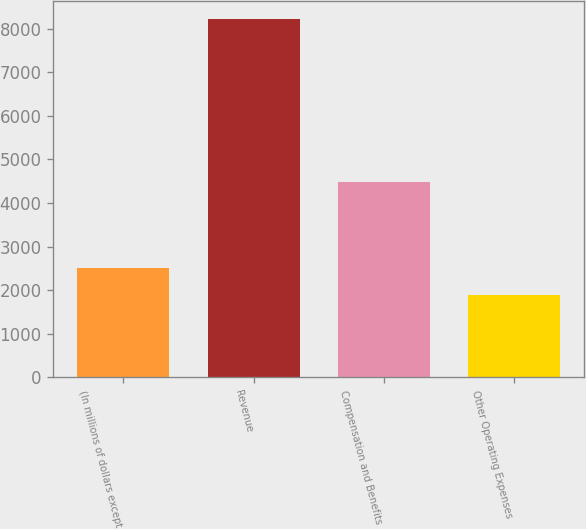Convert chart. <chart><loc_0><loc_0><loc_500><loc_500><bar_chart><fcel>(In millions of dollars except<fcel>Revenue<fcel>Compensation and Benefits<fcel>Other Operating Expenses<nl><fcel>2513.9<fcel>8228<fcel>4485<fcel>1879<nl></chart> 